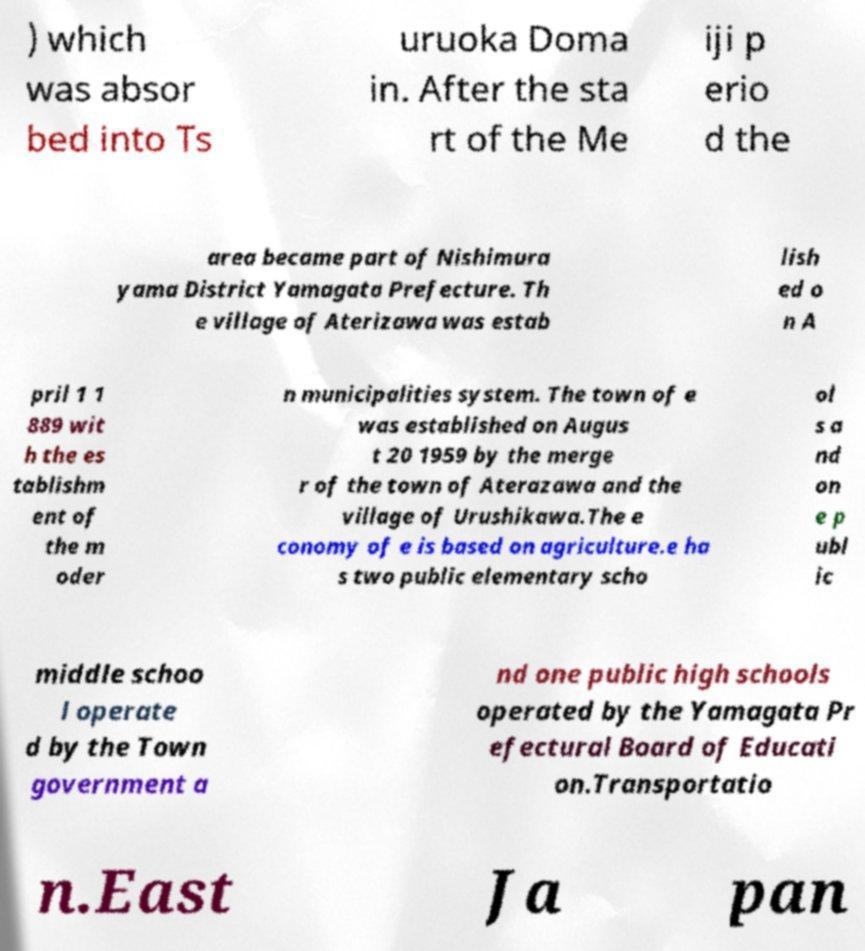Please read and relay the text visible in this image. What does it say? ) which was absor bed into Ts uruoka Doma in. After the sta rt of the Me iji p erio d the area became part of Nishimura yama District Yamagata Prefecture. Th e village of Aterizawa was estab lish ed o n A pril 1 1 889 wit h the es tablishm ent of the m oder n municipalities system. The town of e was established on Augus t 20 1959 by the merge r of the town of Aterazawa and the village of Urushikawa.The e conomy of e is based on agriculture.e ha s two public elementary scho ol s a nd on e p ubl ic middle schoo l operate d by the Town government a nd one public high schools operated by the Yamagata Pr efectural Board of Educati on.Transportatio n.East Ja pan 